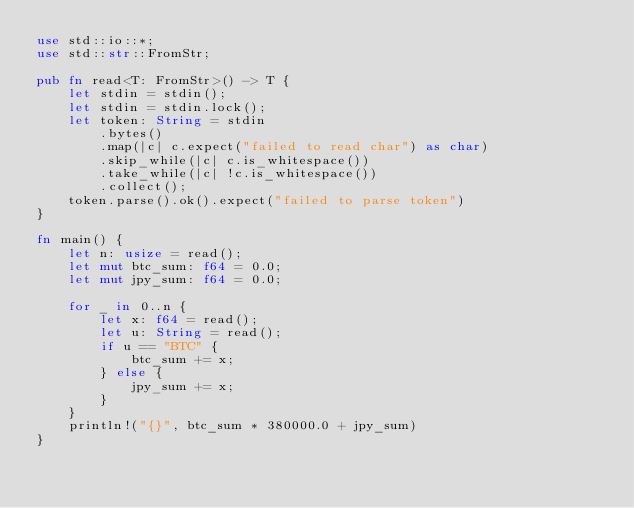Convert code to text. <code><loc_0><loc_0><loc_500><loc_500><_Rust_>use std::io::*;
use std::str::FromStr;

pub fn read<T: FromStr>() -> T {
    let stdin = stdin();
    let stdin = stdin.lock();
    let token: String = stdin
        .bytes()
        .map(|c| c.expect("failed to read char") as char)
        .skip_while(|c| c.is_whitespace())
        .take_while(|c| !c.is_whitespace())
        .collect();
    token.parse().ok().expect("failed to parse token")
}

fn main() {
    let n: usize = read();
    let mut btc_sum: f64 = 0.0;
    let mut jpy_sum: f64 = 0.0;

    for _ in 0..n {
        let x: f64 = read();
        let u: String = read();
        if u == "BTC" {
            btc_sum += x;
        } else {
            jpy_sum += x;
        }
    }
    println!("{}", btc_sum * 380000.0 + jpy_sum)
}
</code> 